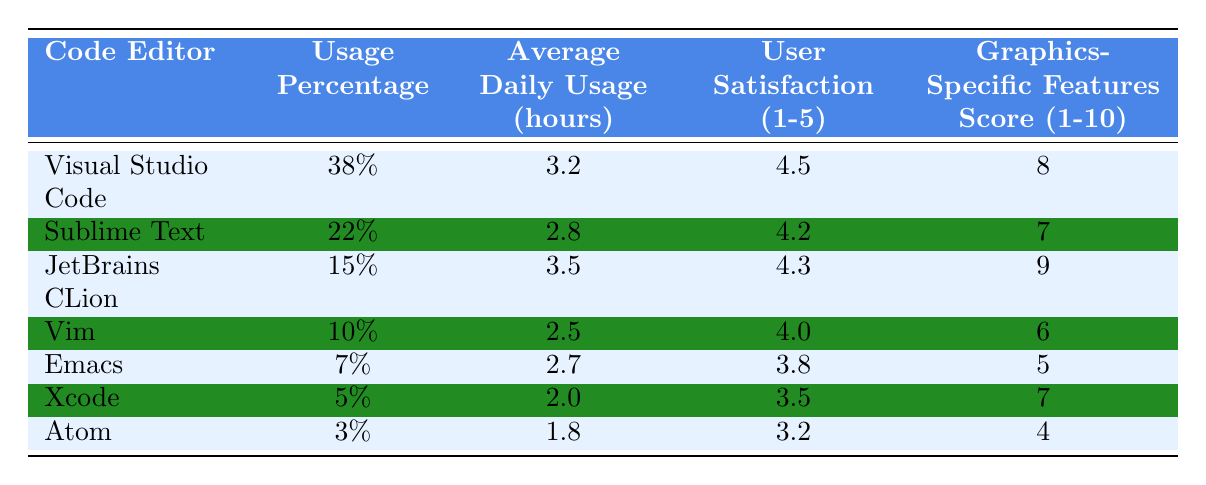What is the most used code editor among computer graphics professionals? The "Usage Percentage" column indicates that Visual Studio Code has the highest percentage at 38%.
Answer: Visual Studio Code Which code editor has the lowest user satisfaction rating? By comparing the "User Satisfaction" ratings, Atom has the lowest rating at 3.2.
Answer: Atom What is the average daily usage of JetBrains CLion? The "Average Daily Usage (hours)" column shows that JetBrains CLion has an average daily usage of 3.5 hours.
Answer: 3.5 hours How many code editors have a user satisfaction rating of 4.0 or higher? The editors with ratings of 4.0 or higher are Visual Studio Code (4.5), Sublime Text (4.2), and JetBrains CLion (4.3). That makes three editors.
Answer: 3 What is the difference in average daily usage between Visual Studio Code and Vim? Visual Studio Code has an average of 3.2 hours and Vim has 2.5 hours. The difference is 3.2 - 2.5 = 0.7 hours.
Answer: 0.7 hours Which code editor has the highest graphics-specific features score? The "Graphics-Specific Features Score" shows JetBrains CLion with a score of 9, which is the highest among all editors listed.
Answer: JetBrains CLion Is it true that more than 50% of computer graphics professionals use Xcode? Xcode has a usage percentage of 5%, which is significantly less than 50%, so the statement is false.
Answer: False What is the total usage percentage of the top three code editors? The usage percentages for the top three editors are 38% (Visual Studio Code), 22% (Sublime Text), and 15% (JetBrains CLion). The total is 38 + 22 + 15 = 75%.
Answer: 75% Which editor has a higher average daily usage, Sublime Text or Emacs? Sublime Text has an average daily usage of 2.8 hours, while Emacs has an average of 2.7 hours. Since 2.8 > 2.7, Sublime Text has a higher usage.
Answer: Sublime Text How would you rank the code editors from highest to lowest based on their graphics-specific features score? The scores are: JetBrains CLion (9), Visual Studio Code (8), Sublime Text (7), Xcode (7), Vim (6), Emacs (5), and Atom (4). The ranking from highest to lowest is: JetBrains CLion, Visual Studio Code, Sublime Text, Xcode, Vim, Emacs, Atom.
Answer: JetBrains CLion, Visual Studio Code, Sublime Text, Xcode, Vim, Emacs, Atom 